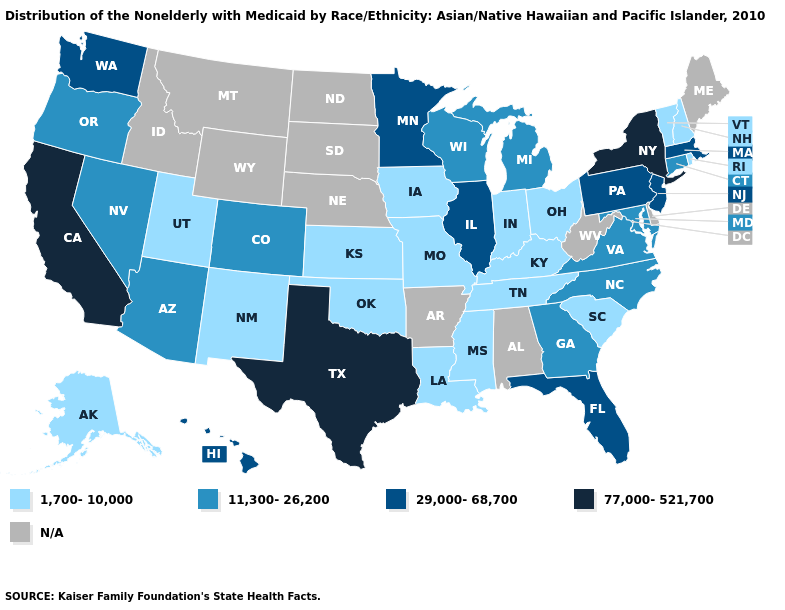Does the map have missing data?
Concise answer only. Yes. What is the highest value in the USA?
Keep it brief. 77,000-521,700. Name the states that have a value in the range 1,700-10,000?
Answer briefly. Alaska, Indiana, Iowa, Kansas, Kentucky, Louisiana, Mississippi, Missouri, New Hampshire, New Mexico, Ohio, Oklahoma, Rhode Island, South Carolina, Tennessee, Utah, Vermont. What is the value of New York?
Short answer required. 77,000-521,700. What is the lowest value in the USA?
Give a very brief answer. 1,700-10,000. Does Ohio have the lowest value in the MidWest?
Give a very brief answer. Yes. What is the value of Maryland?
Short answer required. 11,300-26,200. Among the states that border Oregon , does Washington have the lowest value?
Give a very brief answer. No. Name the states that have a value in the range 11,300-26,200?
Give a very brief answer. Arizona, Colorado, Connecticut, Georgia, Maryland, Michigan, Nevada, North Carolina, Oregon, Virginia, Wisconsin. What is the highest value in the USA?
Quick response, please. 77,000-521,700. How many symbols are there in the legend?
Give a very brief answer. 5. Among the states that border New Jersey , does Pennsylvania have the lowest value?
Be succinct. Yes. Does the map have missing data?
Answer briefly. Yes. Name the states that have a value in the range 11,300-26,200?
Answer briefly. Arizona, Colorado, Connecticut, Georgia, Maryland, Michigan, Nevada, North Carolina, Oregon, Virginia, Wisconsin. 